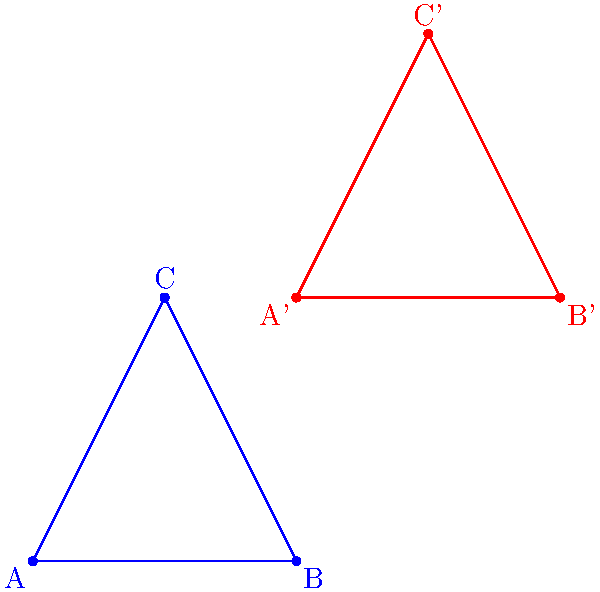As a software engineer familiar with coordinate systems, analyze the transformation of triangle ABC to A'B'C'. Determine the type of transformation and its parameters. The coordinates are:
A(1,1), B(3,1), C(2,3)
A'(3,3), B'(5,3), C'(4,5) Let's approach this step-by-step:

1) First, we need to determine how each point has moved:
   A(1,1) → A'(3,3): moved 2 units right, 2 units up
   B(3,1) → B'(5,3): moved 2 units right, 2 units up
   C(2,3) → C'(4,5): moved 2 units right, 2 units up

2) We observe that all points have moved by the same amount and in the same direction. This is characteristic of a translation.

3) To find the translation vector, we can subtract the coordinates of any original point from its image:
   $\vec{v} = A' - A = (3-1, 3-1) = (2, 2)$
   
   We can verify this with the other points:
   $B' - B = (5-3, 3-1) = (2, 2)$
   $C' - C = (4-2, 5-3) = (2, 2)$

4) The translation vector $\vec{v} = (2, 2)$ means that every point of the original triangle has been moved 2 units to the right and 2 units up.

5) In mathematical notation, this translation can be expressed as:
   $(x, y) \rightarrow (x+2, y+2)$
Answer: Translation by vector $(2, 2)$ 